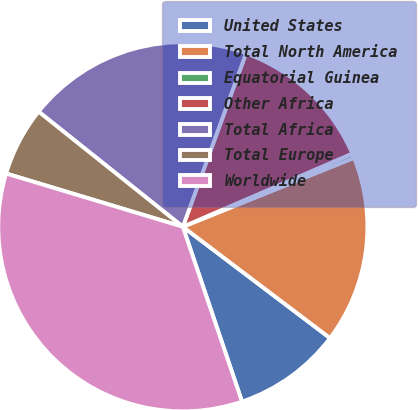Convert chart to OTSL. <chart><loc_0><loc_0><loc_500><loc_500><pie_chart><fcel>United States<fcel>Total North America<fcel>Equatorial Guinea<fcel>Other Africa<fcel>Total Africa<fcel>Total Europe<fcel>Worldwide<nl><fcel>9.5%<fcel>16.4%<fcel>0.39%<fcel>12.95%<fcel>19.84%<fcel>6.06%<fcel>34.85%<nl></chart> 